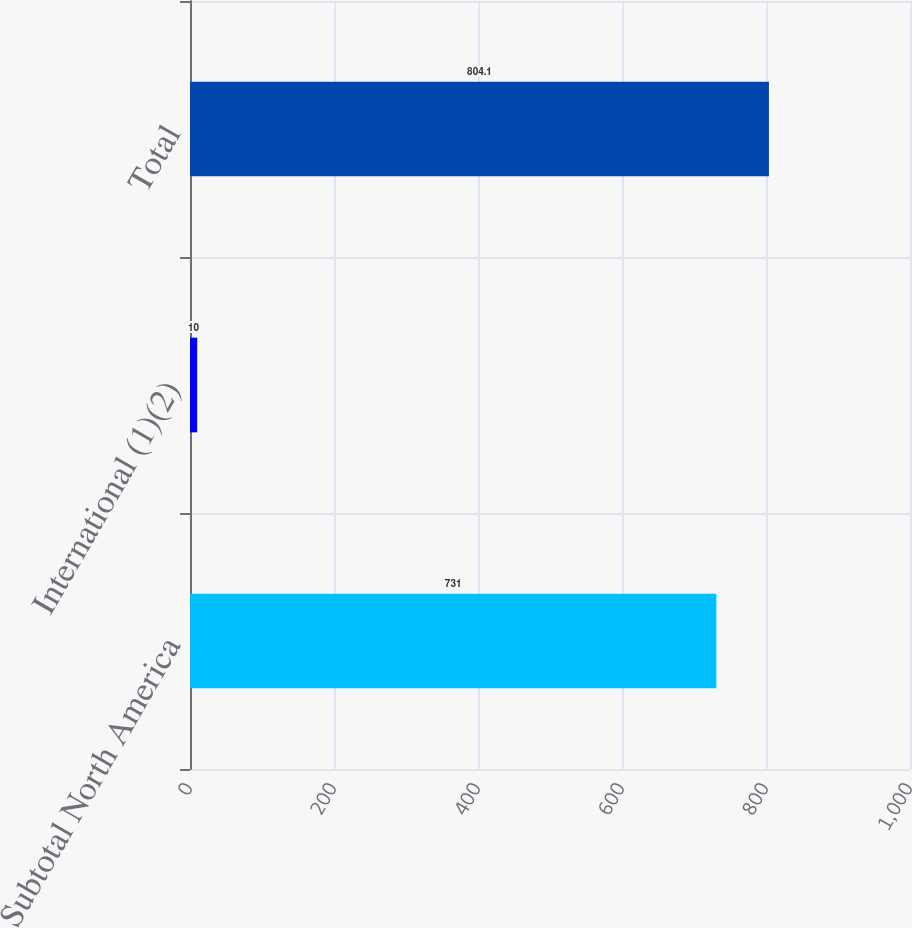Convert chart. <chart><loc_0><loc_0><loc_500><loc_500><bar_chart><fcel>Subtotal North America<fcel>International (1)(2)<fcel>Total<nl><fcel>731<fcel>10<fcel>804.1<nl></chart> 